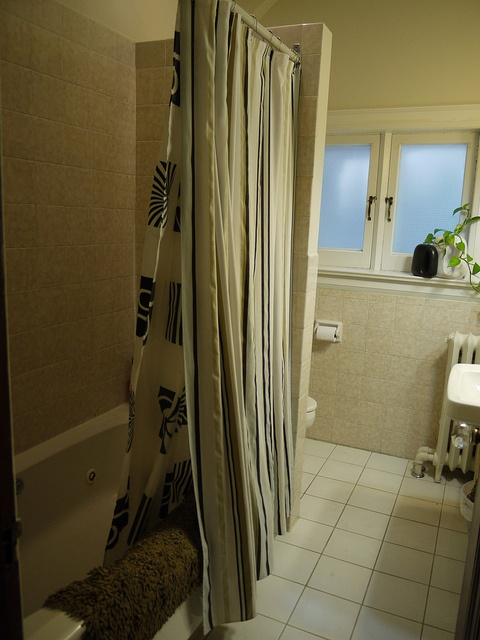Describe the objects in this image and their specific colors. I can see potted plant in black, darkgray, darkgreen, olive, and gray tones, sink in black, beige, darkgray, and gray tones, and toilet in black and tan tones in this image. 